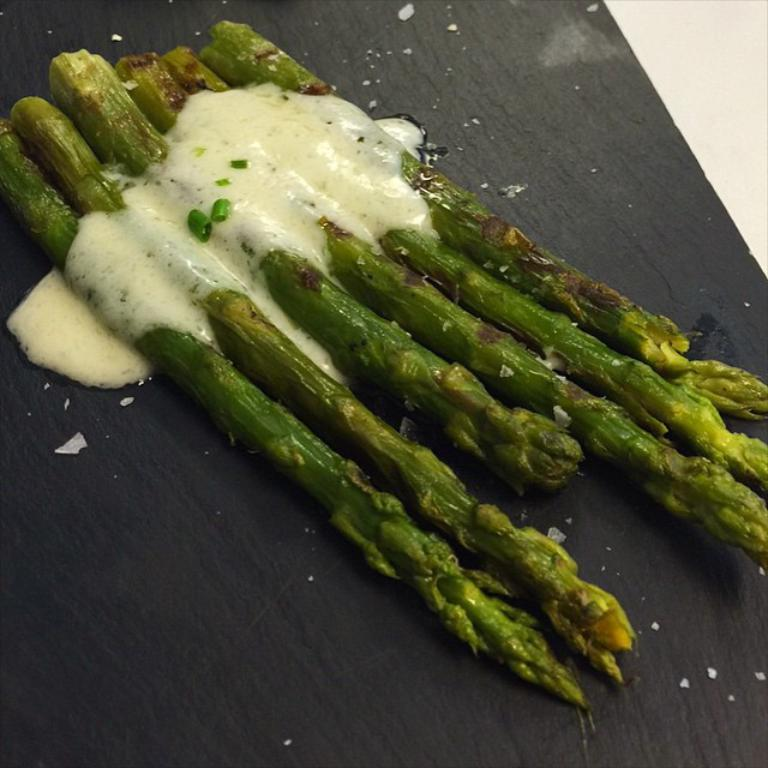What is the primary color of the surface in the image? The primary color of the surface in the image is black. What type of food is present on the black surface? There are vegetable sticks on the black on the black surface. What is the other substance on the black surface with the vegetable sticks? There is cream on the black surface with the vegetable sticks. What scent can be detected from the grass in the image? There is no grass present in the image, so it is not possible to detect any scent from it. 